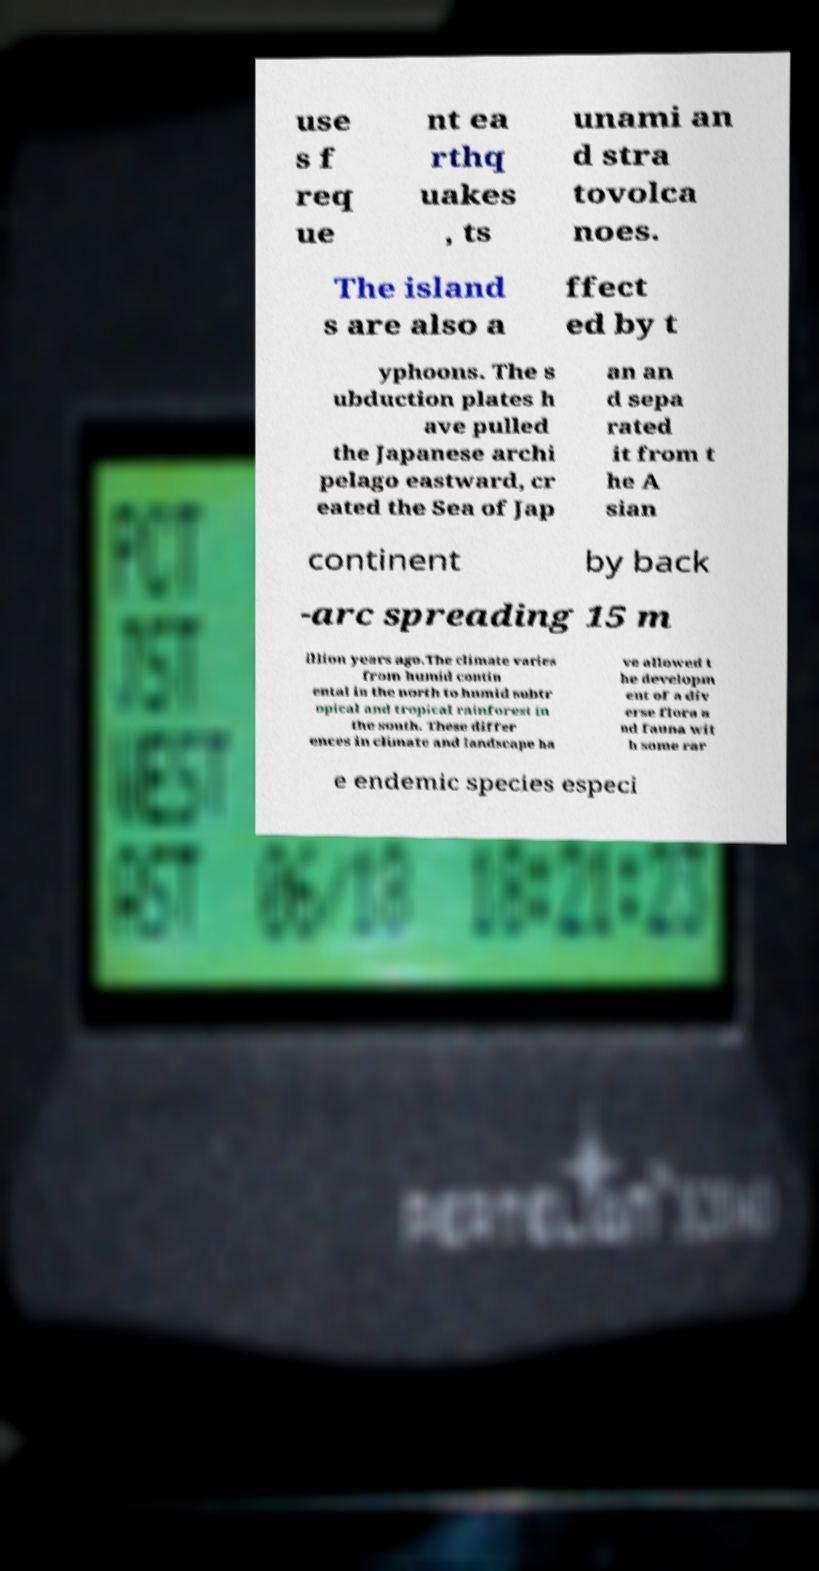There's text embedded in this image that I need extracted. Can you transcribe it verbatim? use s f req ue nt ea rthq uakes , ts unami an d stra tovolca noes. The island s are also a ffect ed by t yphoons. The s ubduction plates h ave pulled the Japanese archi pelago eastward, cr eated the Sea of Jap an an d sepa rated it from t he A sian continent by back -arc spreading 15 m illion years ago.The climate varies from humid contin ental in the north to humid subtr opical and tropical rainforest in the south. These differ ences in climate and landscape ha ve allowed t he developm ent of a div erse flora a nd fauna wit h some rar e endemic species especi 